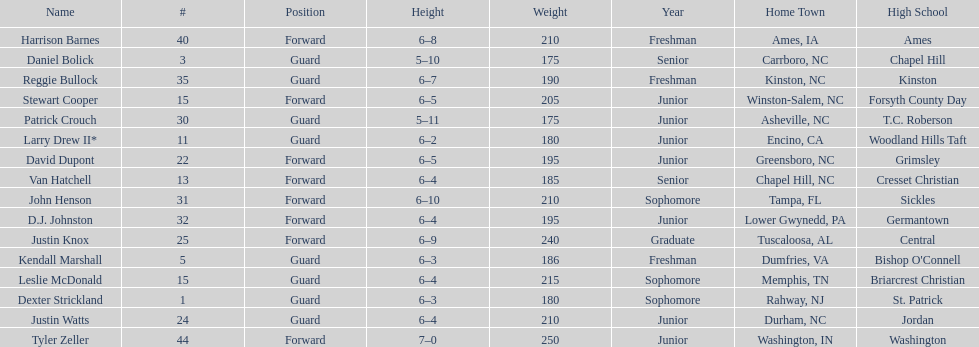Could you help me parse every detail presented in this table? {'header': ['Name', '#', 'Position', 'Height', 'Weight', 'Year', 'Home Town', 'High School'], 'rows': [['Harrison Barnes', '40', 'Forward', '6–8', '210', 'Freshman', 'Ames, IA', 'Ames'], ['Daniel Bolick', '3', 'Guard', '5–10', '175', 'Senior', 'Carrboro, NC', 'Chapel Hill'], ['Reggie Bullock', '35', 'Guard', '6–7', '190', 'Freshman', 'Kinston, NC', 'Kinston'], ['Stewart Cooper', '15', 'Forward', '6–5', '205', 'Junior', 'Winston-Salem, NC', 'Forsyth County Day'], ['Patrick Crouch', '30', 'Guard', '5–11', '175', 'Junior', 'Asheville, NC', 'T.C. Roberson'], ['Larry Drew II*', '11', 'Guard', '6–2', '180', 'Junior', 'Encino, CA', 'Woodland Hills Taft'], ['David Dupont', '22', 'Forward', '6–5', '195', 'Junior', 'Greensboro, NC', 'Grimsley'], ['Van Hatchell', '13', 'Forward', '6–4', '185', 'Senior', 'Chapel Hill, NC', 'Cresset Christian'], ['John Henson', '31', 'Forward', '6–10', '210', 'Sophomore', 'Tampa, FL', 'Sickles'], ['D.J. Johnston', '32', 'Forward', '6–4', '195', 'Junior', 'Lower Gwynedd, PA', 'Germantown'], ['Justin Knox', '25', 'Forward', '6–9', '240', 'Graduate', 'Tuscaloosa, AL', 'Central'], ['Kendall Marshall', '5', 'Guard', '6–3', '186', 'Freshman', 'Dumfries, VA', "Bishop O'Connell"], ['Leslie McDonald', '15', 'Guard', '6–4', '215', 'Sophomore', 'Memphis, TN', 'Briarcrest Christian'], ['Dexter Strickland', '1', 'Guard', '6–3', '180', 'Sophomore', 'Rahway, NJ', 'St. Patrick'], ['Justin Watts', '24', 'Guard', '6–4', '210', 'Junior', 'Durham, NC', 'Jordan'], ['Tyler Zeller', '44', 'Forward', '7–0', '250', 'Junior', 'Washington, IN', 'Washington']]} How many players play a position other than guard? 8. 